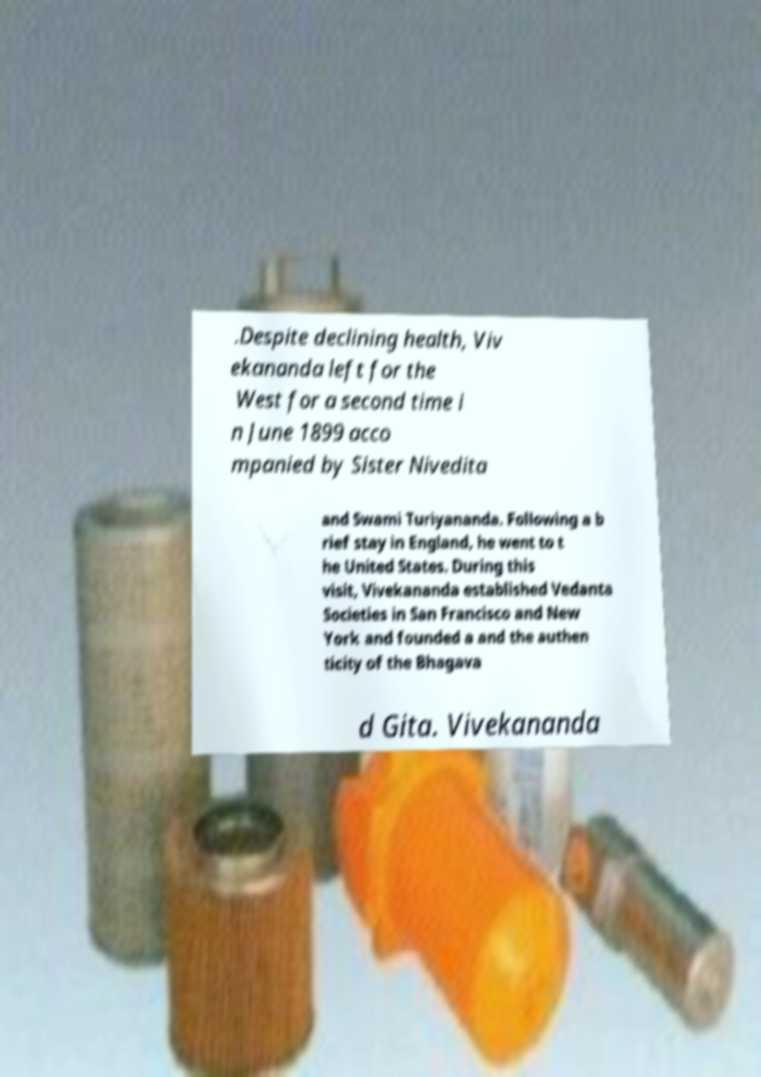For documentation purposes, I need the text within this image transcribed. Could you provide that? .Despite declining health, Viv ekananda left for the West for a second time i n June 1899 acco mpanied by Sister Nivedita and Swami Turiyananda. Following a b rief stay in England, he went to t he United States. During this visit, Vivekananda established Vedanta Societies in San Francisco and New York and founded a and the authen ticity of the Bhagava d Gita. Vivekananda 